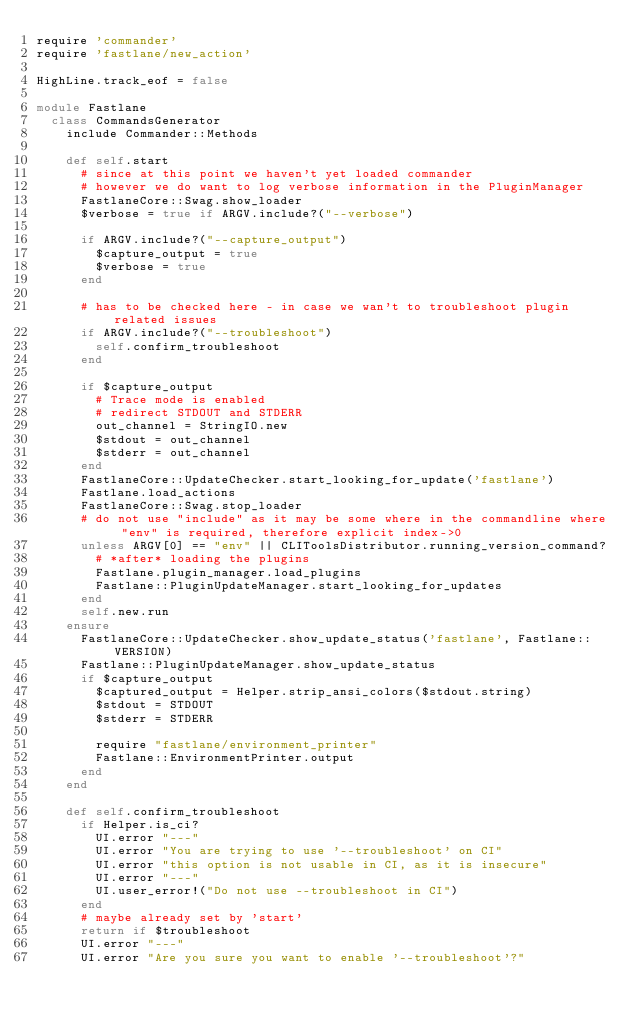Convert code to text. <code><loc_0><loc_0><loc_500><loc_500><_Ruby_>require 'commander'
require 'fastlane/new_action'

HighLine.track_eof = false

module Fastlane
  class CommandsGenerator
    include Commander::Methods

    def self.start
      # since at this point we haven't yet loaded commander
      # however we do want to log verbose information in the PluginManager
      FastlaneCore::Swag.show_loader
      $verbose = true if ARGV.include?("--verbose")

      if ARGV.include?("--capture_output")
        $capture_output = true
        $verbose = true
      end

      # has to be checked here - in case we wan't to troubleshoot plugin related issues
      if ARGV.include?("--troubleshoot")
        self.confirm_troubleshoot
      end

      if $capture_output
        # Trace mode is enabled
        # redirect STDOUT and STDERR
        out_channel = StringIO.new
        $stdout = out_channel
        $stderr = out_channel
      end
      FastlaneCore::UpdateChecker.start_looking_for_update('fastlane')
      Fastlane.load_actions
      FastlaneCore::Swag.stop_loader
      # do not use "include" as it may be some where in the commandline where "env" is required, therefore explicit index->0
      unless ARGV[0] == "env" || CLIToolsDistributor.running_version_command?
        # *after* loading the plugins
        Fastlane.plugin_manager.load_plugins
        Fastlane::PluginUpdateManager.start_looking_for_updates
      end
      self.new.run
    ensure
      FastlaneCore::UpdateChecker.show_update_status('fastlane', Fastlane::VERSION)
      Fastlane::PluginUpdateManager.show_update_status
      if $capture_output
        $captured_output = Helper.strip_ansi_colors($stdout.string)
        $stdout = STDOUT
        $stderr = STDERR

        require "fastlane/environment_printer"
        Fastlane::EnvironmentPrinter.output
      end
    end

    def self.confirm_troubleshoot
      if Helper.is_ci?
        UI.error "---"
        UI.error "You are trying to use '--troubleshoot' on CI"
        UI.error "this option is not usable in CI, as it is insecure"
        UI.error "---"
        UI.user_error!("Do not use --troubleshoot in CI")
      end
      # maybe already set by 'start'
      return if $troubleshoot
      UI.error "---"
      UI.error "Are you sure you want to enable '--troubleshoot'?"</code> 